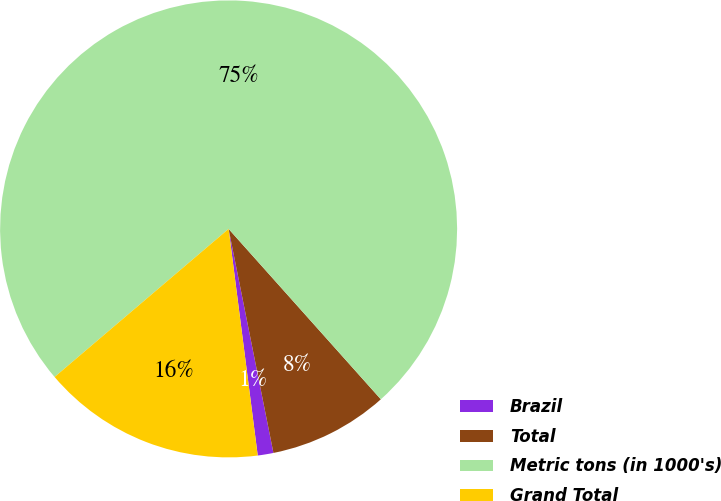Convert chart. <chart><loc_0><loc_0><loc_500><loc_500><pie_chart><fcel>Brazil<fcel>Total<fcel>Metric tons (in 1000's)<fcel>Grand Total<nl><fcel>1.11%<fcel>8.46%<fcel>74.61%<fcel>15.81%<nl></chart> 